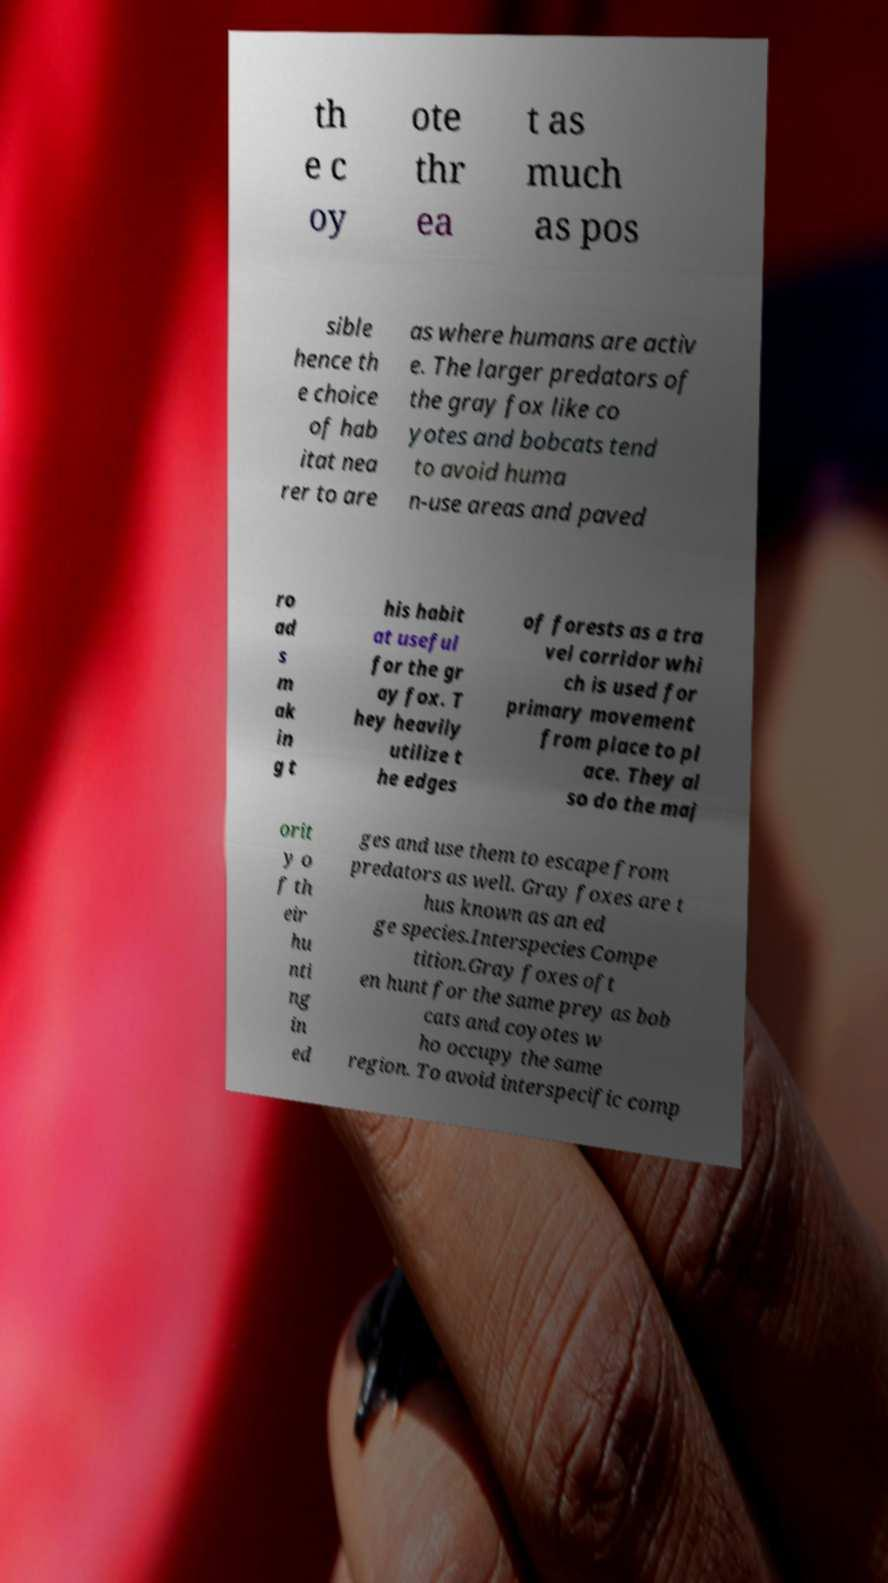Could you extract and type out the text from this image? th e c oy ote thr ea t as much as pos sible hence th e choice of hab itat nea rer to are as where humans are activ e. The larger predators of the gray fox like co yotes and bobcats tend to avoid huma n-use areas and paved ro ad s m ak in g t his habit at useful for the gr ay fox. T hey heavily utilize t he edges of forests as a tra vel corridor whi ch is used for primary movement from place to pl ace. They al so do the maj orit y o f th eir hu nti ng in ed ges and use them to escape from predators as well. Gray foxes are t hus known as an ed ge species.Interspecies Compe tition.Gray foxes oft en hunt for the same prey as bob cats and coyotes w ho occupy the same region. To avoid interspecific comp 